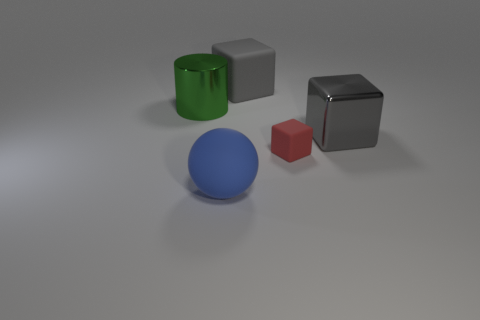Is there anything else that is made of the same material as the small thing?
Ensure brevity in your answer.  Yes. There is a big object that is in front of the green object and left of the small red rubber object; what is its color?
Your answer should be very brief. Blue. Are the red block and the big gray cube that is on the right side of the big gray matte cube made of the same material?
Offer a terse response. No. Is the number of metallic cylinders that are in front of the metallic cylinder less than the number of metal cylinders?
Your answer should be very brief. Yes. How many other objects are there of the same shape as the big blue matte thing?
Offer a terse response. 0. Are there any other things that are the same color as the tiny cube?
Your answer should be compact. No. There is a big sphere; is its color the same as the large metallic thing in front of the green metallic object?
Offer a terse response. No. What number of other things are there of the same size as the rubber ball?
Your response must be concise. 3. What is the size of the thing that is the same color as the large rubber cube?
Offer a very short reply. Large. What number of cylinders are either tiny cyan shiny objects or green metal things?
Your answer should be very brief. 1. 